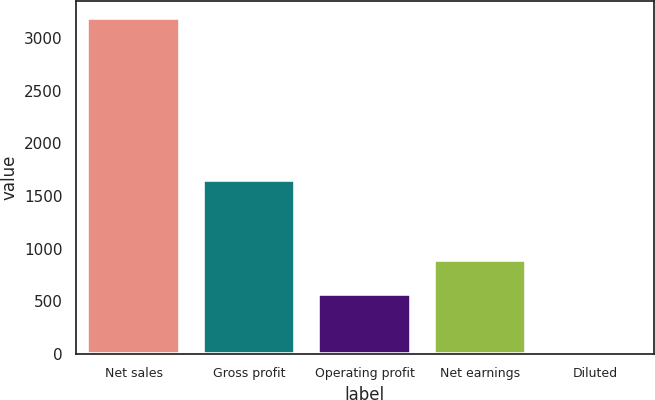Convert chart to OTSL. <chart><loc_0><loc_0><loc_500><loc_500><bar_chart><fcel>Net sales<fcel>Gross profit<fcel>Operating profit<fcel>Net earnings<fcel>Diluted<nl><fcel>3190.2<fcel>1648.8<fcel>572.7<fcel>891.62<fcel>0.95<nl></chart> 